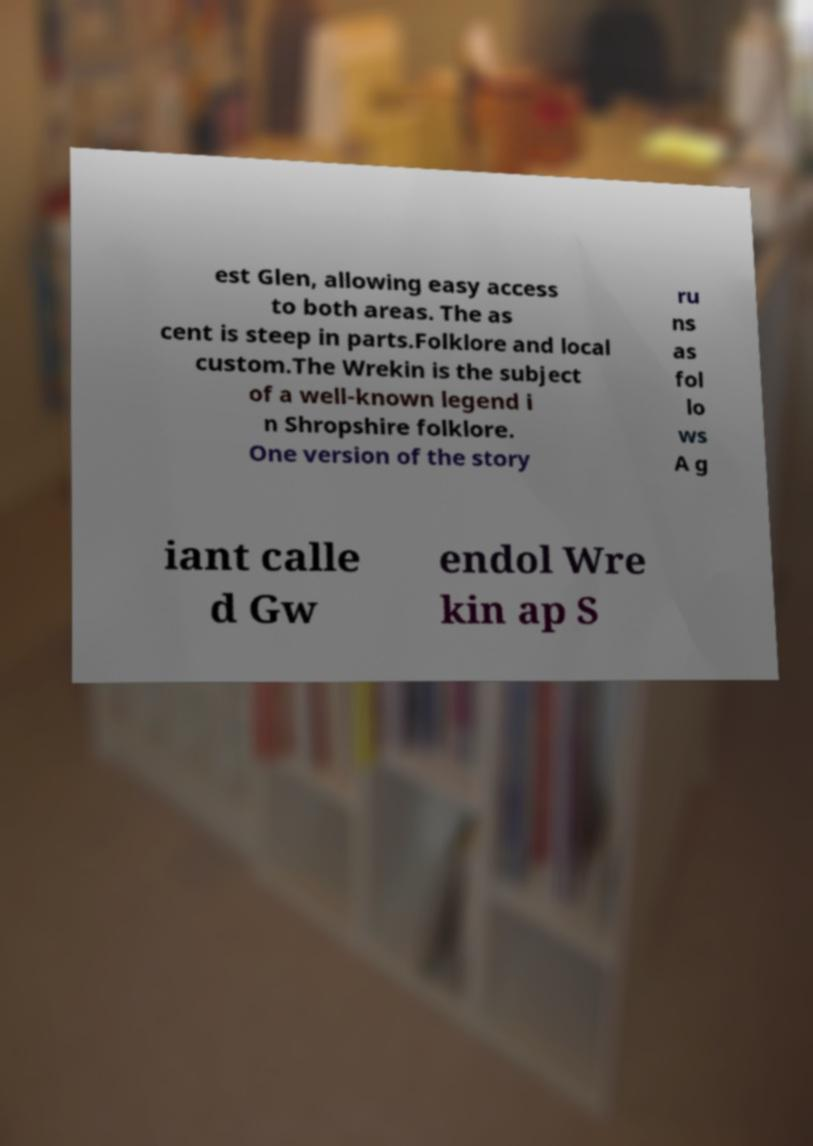Could you assist in decoding the text presented in this image and type it out clearly? est Glen, allowing easy access to both areas. The as cent is steep in parts.Folklore and local custom.The Wrekin is the subject of a well-known legend i n Shropshire folklore. One version of the story ru ns as fol lo ws A g iant calle d Gw endol Wre kin ap S 